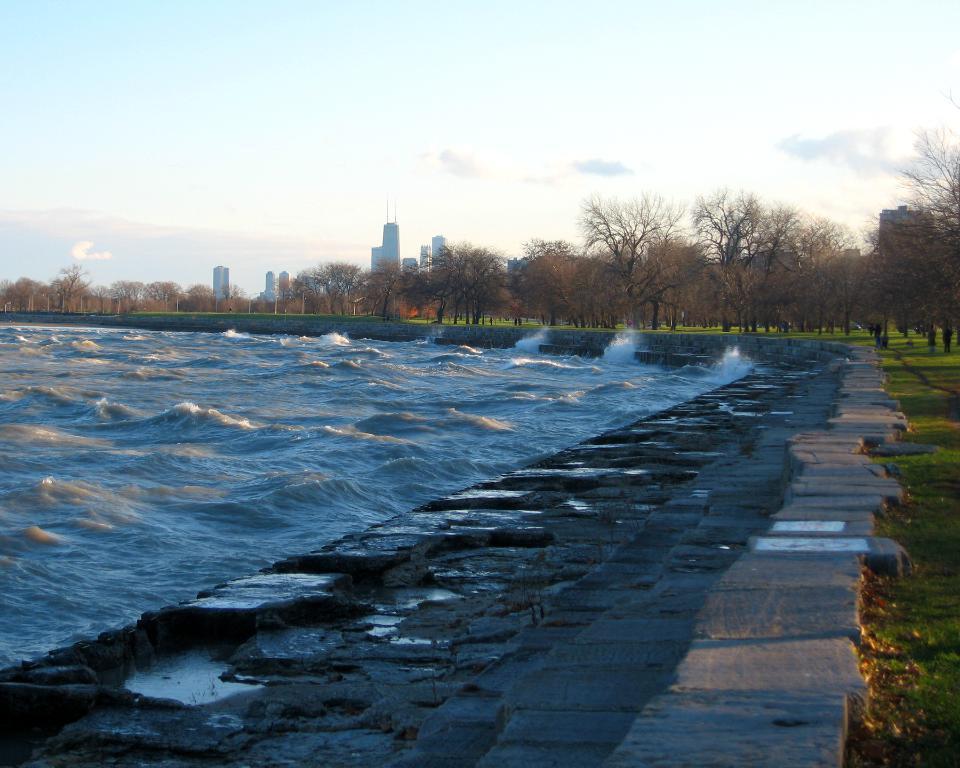In one or two sentences, can you explain what this image depicts? In this picture we can see the grass, water, steps, stones, trees, buildings and in the background we can see the sky. 